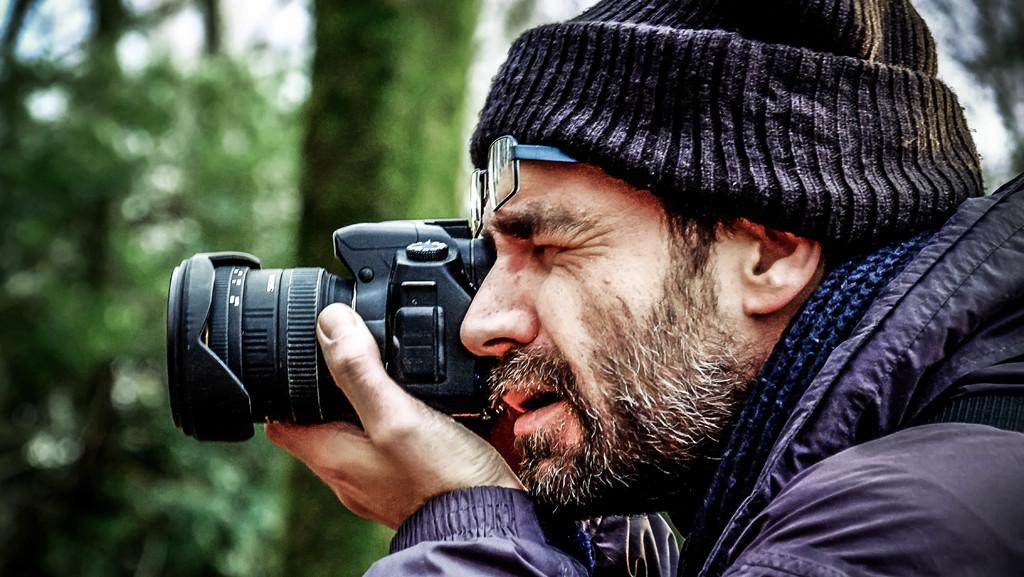What is the main subject of the image? There is a person in the image. What is the person doing in the image? The person is holding a camera near his eye. Can you describe the person's clothing in the image? The person is wearing a cap and a jacket. What can be seen on the left side of the image? There are trees on the left side of the image. What type of paint is being used to create a copy of the image? There is no paint or copying process present in the image; it is a photograph of a person holding a camera. 